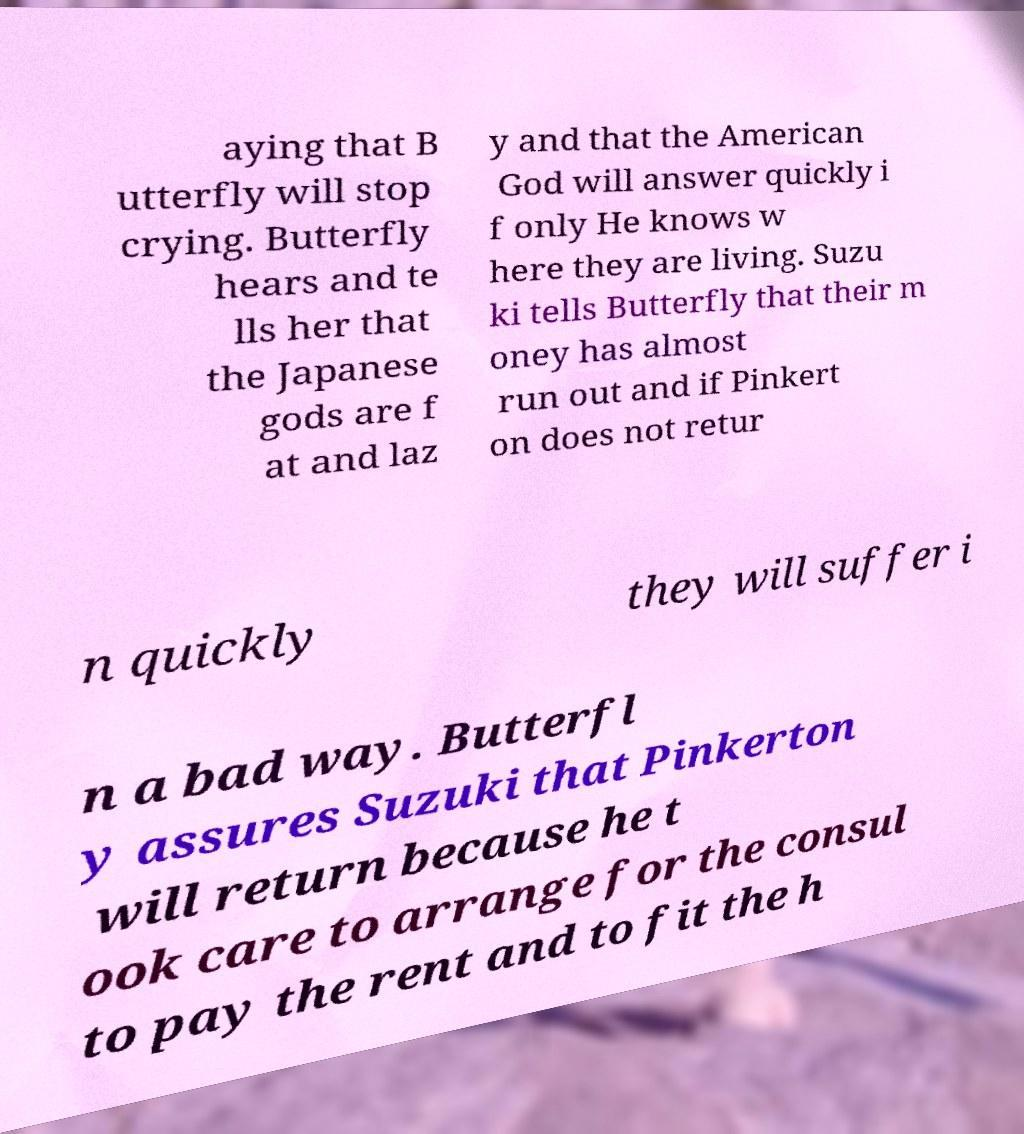Can you accurately transcribe the text from the provided image for me? aying that B utterfly will stop crying. Butterfly hears and te lls her that the Japanese gods are f at and laz y and that the American God will answer quickly i f only He knows w here they are living. Suzu ki tells Butterfly that their m oney has almost run out and if Pinkert on does not retur n quickly they will suffer i n a bad way. Butterfl y assures Suzuki that Pinkerton will return because he t ook care to arrange for the consul to pay the rent and to fit the h 